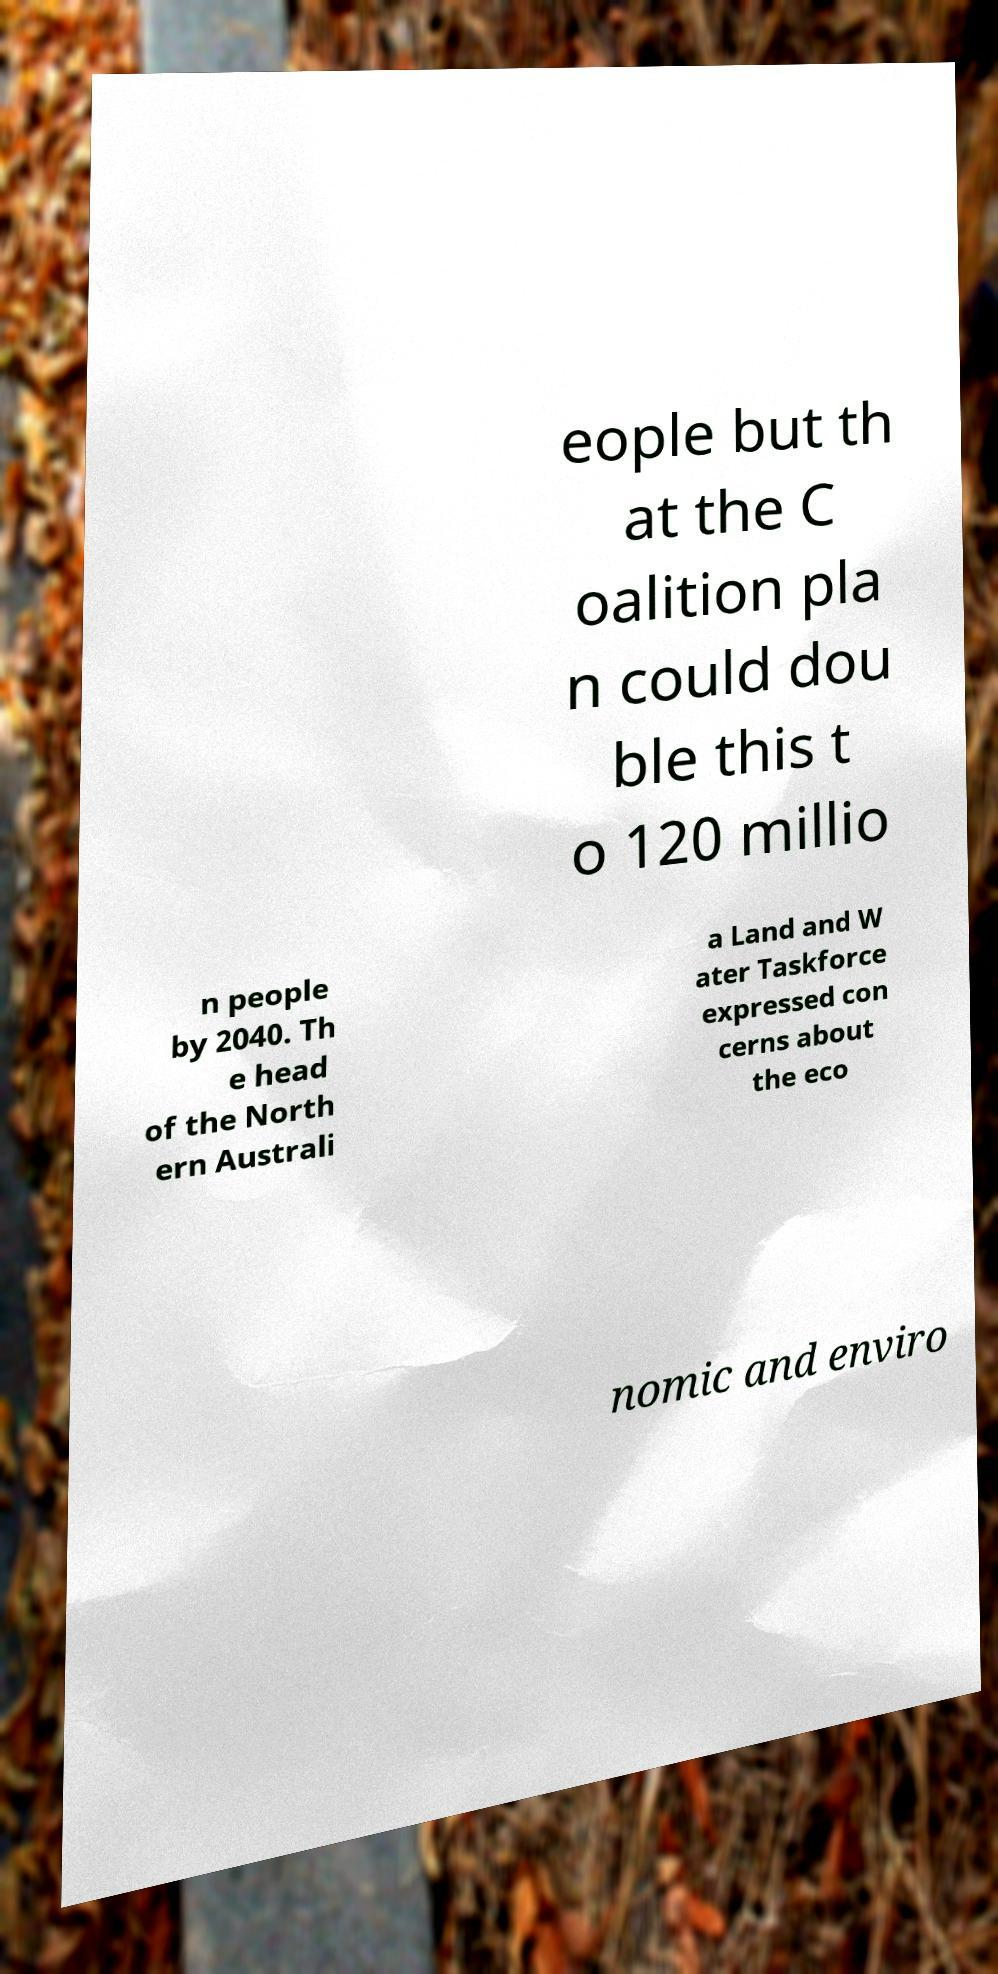There's text embedded in this image that I need extracted. Can you transcribe it verbatim? eople but th at the C oalition pla n could dou ble this t o 120 millio n people by 2040. Th e head of the North ern Australi a Land and W ater Taskforce expressed con cerns about the eco nomic and enviro 